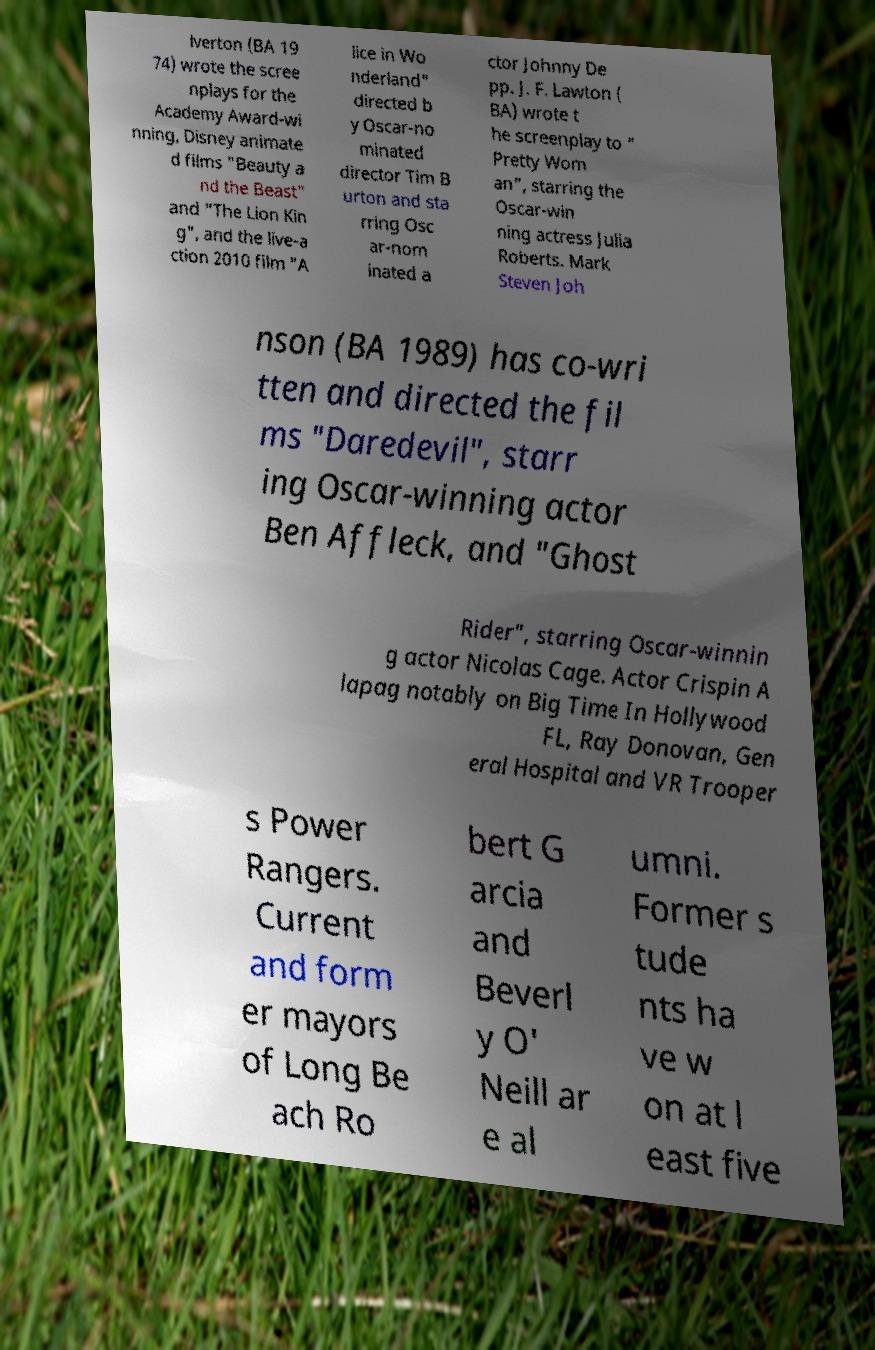For documentation purposes, I need the text within this image transcribed. Could you provide that? lverton (BA 19 74) wrote the scree nplays for the Academy Award-wi nning, Disney animate d films "Beauty a nd the Beast" and "The Lion Kin g", and the live-a ction 2010 film "A lice in Wo nderland" directed b y Oscar-no minated director Tim B urton and sta rring Osc ar-nom inated a ctor Johnny De pp. J. F. Lawton ( BA) wrote t he screenplay to " Pretty Wom an", starring the Oscar-win ning actress Julia Roberts. Mark Steven Joh nson (BA 1989) has co-wri tten and directed the fil ms "Daredevil", starr ing Oscar-winning actor Ben Affleck, and "Ghost Rider", starring Oscar-winnin g actor Nicolas Cage. Actor Crispin A lapag notably on Big Time In Hollywood FL, Ray Donovan, Gen eral Hospital and VR Trooper s Power Rangers. Current and form er mayors of Long Be ach Ro bert G arcia and Beverl y O' Neill ar e al umni. Former s tude nts ha ve w on at l east five 